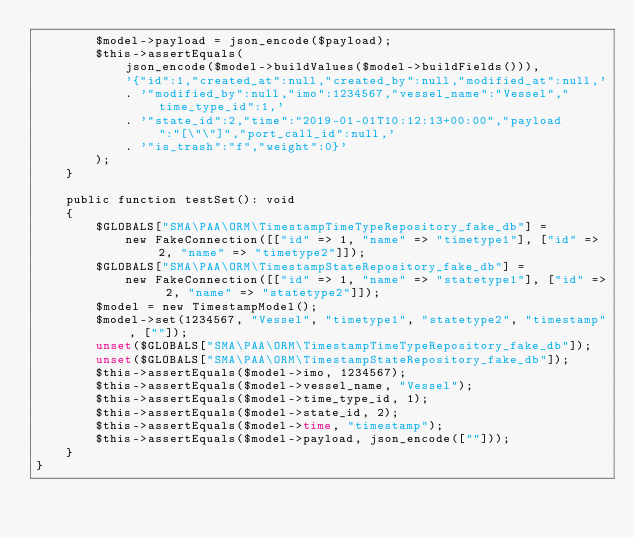<code> <loc_0><loc_0><loc_500><loc_500><_PHP_>        $model->payload = json_encode($payload);
        $this->assertEquals(
            json_encode($model->buildValues($model->buildFields())),
            '{"id":1,"created_at":null,"created_by":null,"modified_at":null,'
            . '"modified_by":null,"imo":1234567,"vessel_name":"Vessel","time_type_id":1,'
            . '"state_id":2,"time":"2019-01-01T10:12:13+00:00","payload":"[\"\"]","port_call_id":null,'
            . '"is_trash":"f","weight":0}'
        );
    }

    public function testSet(): void
    {
        $GLOBALS["SMA\PAA\ORM\TimestampTimeTypeRepository_fake_db"] =
            new FakeConnection([["id" => 1, "name" => "timetype1"], ["id" => 2, "name" => "timetype2"]]);
        $GLOBALS["SMA\PAA\ORM\TimestampStateRepository_fake_db"] =
            new FakeConnection([["id" => 1, "name" => "statetype1"], ["id" => 2, "name" => "statetype2"]]);
        $model = new TimestampModel();
        $model->set(1234567, "Vessel", "timetype1", "statetype2", "timestamp", [""]);
        unset($GLOBALS["SMA\PAA\ORM\TimestampTimeTypeRepository_fake_db"]);
        unset($GLOBALS["SMA\PAA\ORM\TimestampStateRepository_fake_db"]);
        $this->assertEquals($model->imo, 1234567);
        $this->assertEquals($model->vessel_name, "Vessel");
        $this->assertEquals($model->time_type_id, 1);
        $this->assertEquals($model->state_id, 2);
        $this->assertEquals($model->time, "timestamp");
        $this->assertEquals($model->payload, json_encode([""]));
    }
}
</code> 